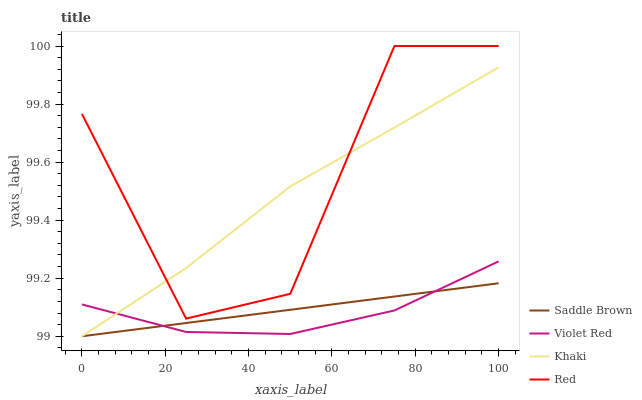Does Violet Red have the minimum area under the curve?
Answer yes or no. Yes. Does Red have the maximum area under the curve?
Answer yes or no. Yes. Does Khaki have the minimum area under the curve?
Answer yes or no. No. Does Khaki have the maximum area under the curve?
Answer yes or no. No. Is Saddle Brown the smoothest?
Answer yes or no. Yes. Is Red the roughest?
Answer yes or no. Yes. Is Khaki the smoothest?
Answer yes or no. No. Is Khaki the roughest?
Answer yes or no. No. Does Red have the lowest value?
Answer yes or no. No. Does Red have the highest value?
Answer yes or no. Yes. Does Khaki have the highest value?
Answer yes or no. No. Is Violet Red less than Red?
Answer yes or no. Yes. Is Red greater than Saddle Brown?
Answer yes or no. Yes. Does Saddle Brown intersect Khaki?
Answer yes or no. Yes. Is Saddle Brown less than Khaki?
Answer yes or no. No. Is Saddle Brown greater than Khaki?
Answer yes or no. No. Does Violet Red intersect Red?
Answer yes or no. No. 